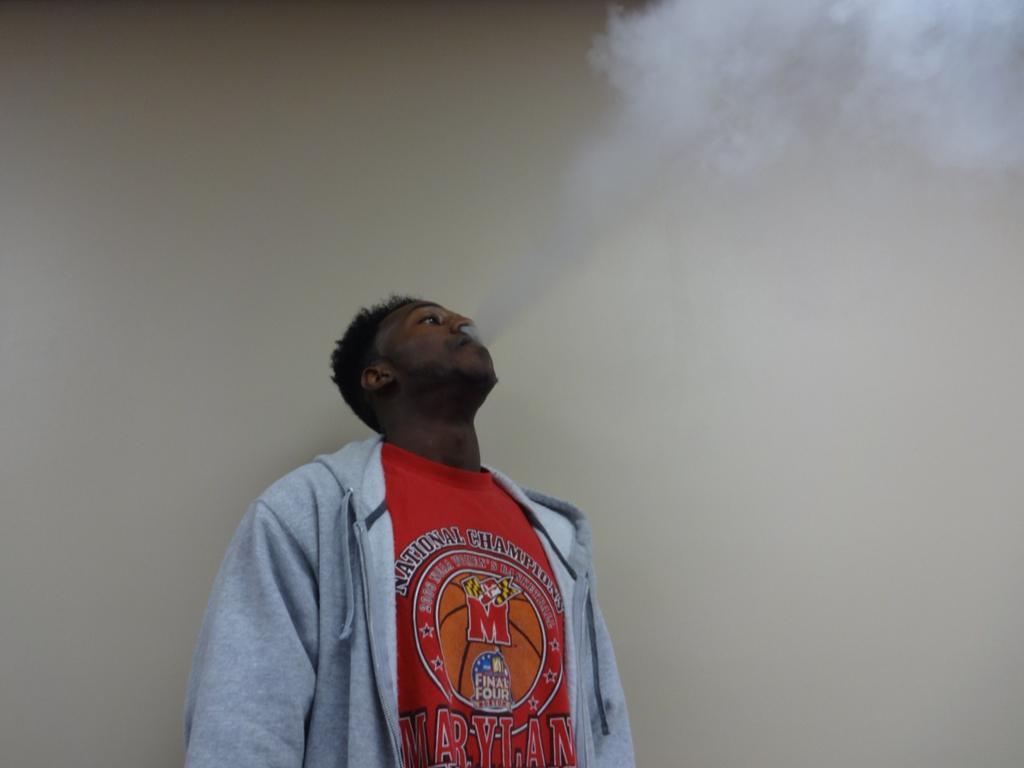<image>
Present a compact description of the photo's key features. A man smokes while wearing a red final four shirt. 